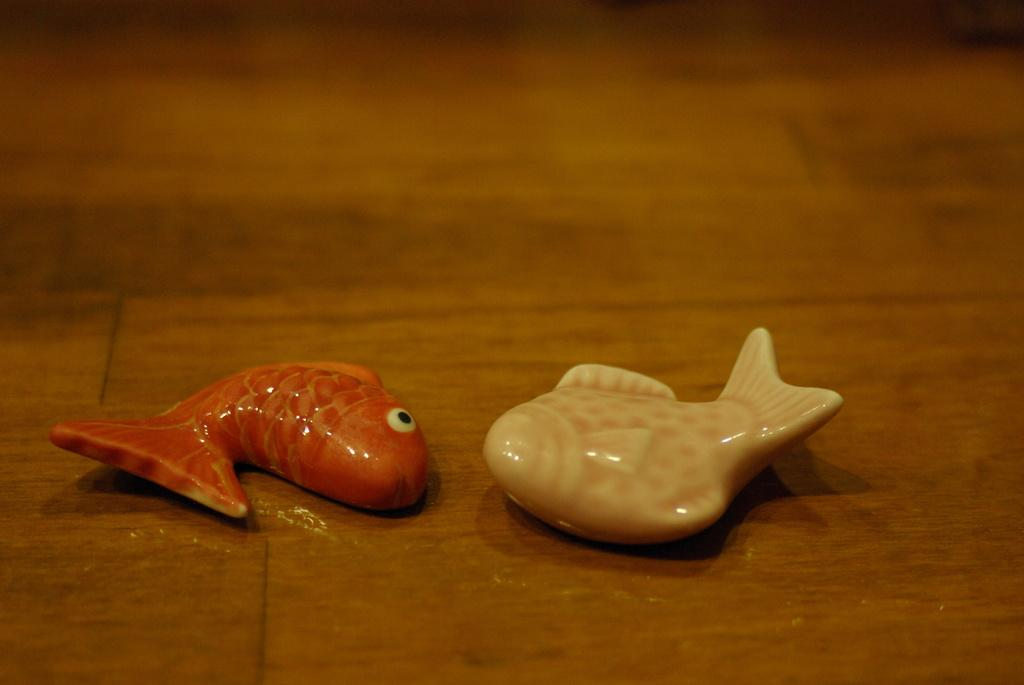What type of toys are in the image? There are fish toys in the image. What is the material of the surface where the toys are placed? The fish toys are on a wooden surface. How many legs does the donkey have in the image? There is no donkey present in the image, so it is not possible to determine the number of legs it might have. 